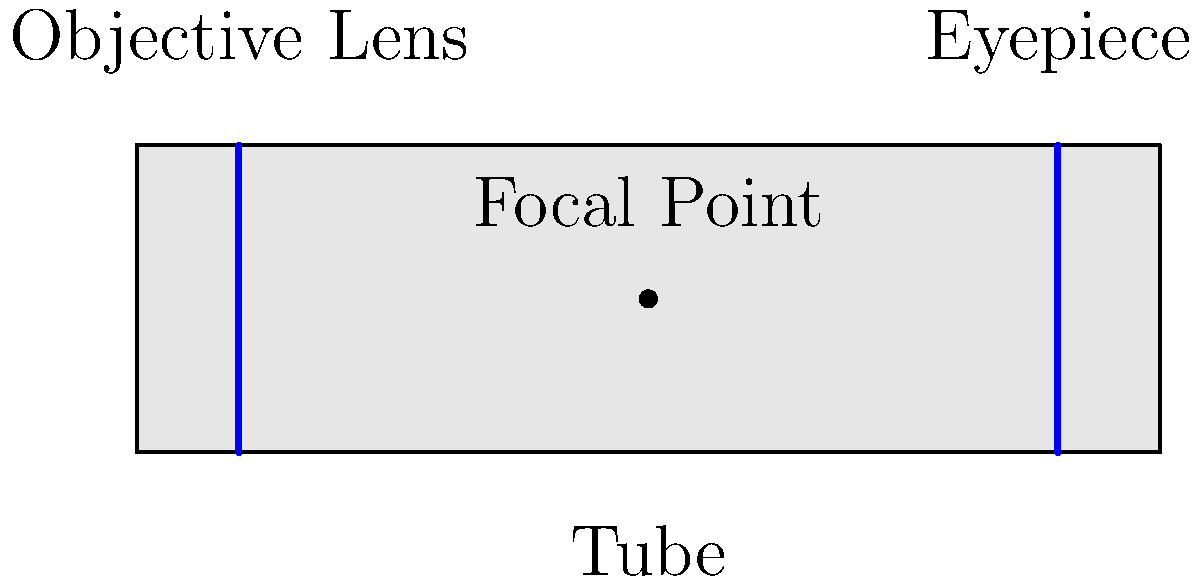In the diagram of a simple refracting telescope, which component is responsible for gathering and focusing light from distant objects? To understand the components of a refracting telescope, let's break down its main parts:

1. Objective Lens: This is the large lens at the front of the telescope (left side in the diagram). It's the primary light-gathering element.

2. Eyepiece: This is the smaller lens at the back of the telescope (right side in the diagram). It's used to magnify the image formed by the objective lens.

3. Tube: This is the body of the telescope that holds all the components in place.

4. Focal Point: This is where the light rays converge after passing through the objective lens.

The objective lens is the key component for gathering and focusing light from distant objects. It works as follows:

1. Light from a distant object enters the telescope through the objective lens.
2. The objective lens bends (refracts) the light rays, causing them to converge at the focal point.
3. This creates a real image of the distant object at the focal point.
4. The eyepiece then magnifies this image for viewing.

The larger the objective lens, the more light it can gather, allowing for observation of fainter objects. This is why the objective lens is crucial for the telescope's light-gathering ability.
Answer: Objective Lens 